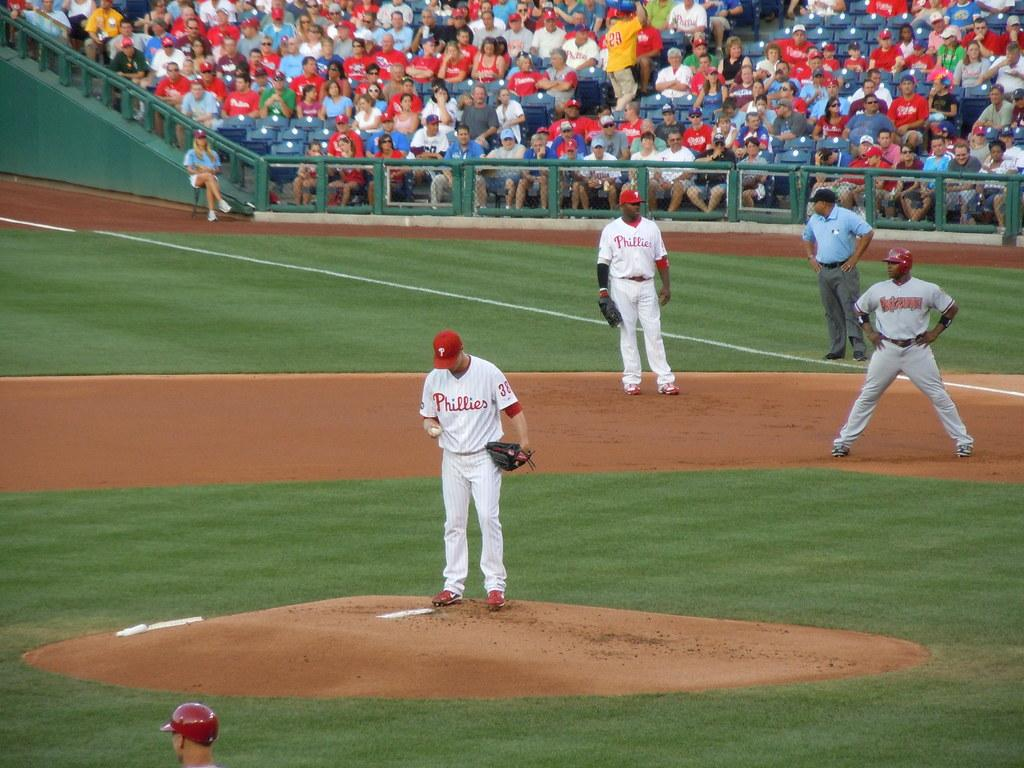<image>
Write a terse but informative summary of the picture. A sports field on which the Phillies are playing baseball. 